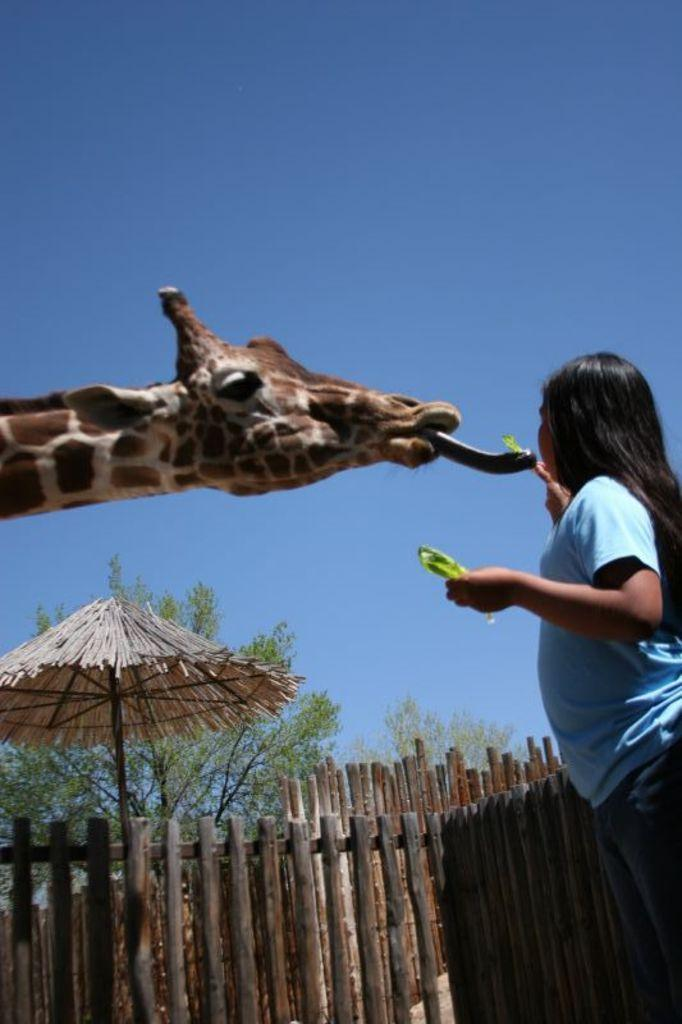What type of animal is in the image? There is a giraffe in the image. Who is present in the image besides the giraffe? There is a woman in the image. What is at the bottom of the image? There is fencing at the bottom of the image. What can be seen in the background of the image? There is an umbrella, trees, and the sky visible in the background of the image. What type of sign can be seen in the image? There is no sign present in the image. What type of wine is being served in the image? There is no wine present in the image. 